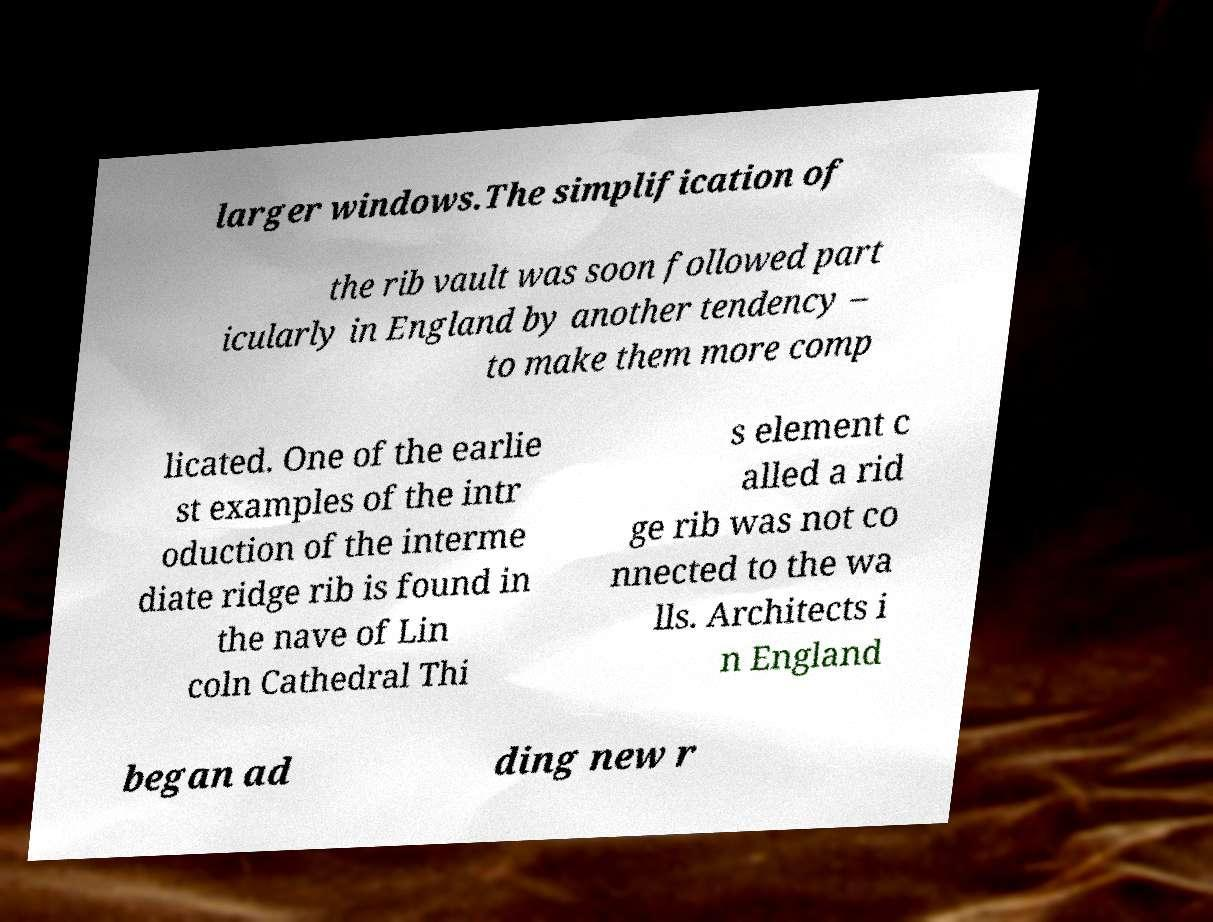What messages or text are displayed in this image? I need them in a readable, typed format. larger windows.The simplification of the rib vault was soon followed part icularly in England by another tendency – to make them more comp licated. One of the earlie st examples of the intr oduction of the interme diate ridge rib is found in the nave of Lin coln Cathedral Thi s element c alled a rid ge rib was not co nnected to the wa lls. Architects i n England began ad ding new r 